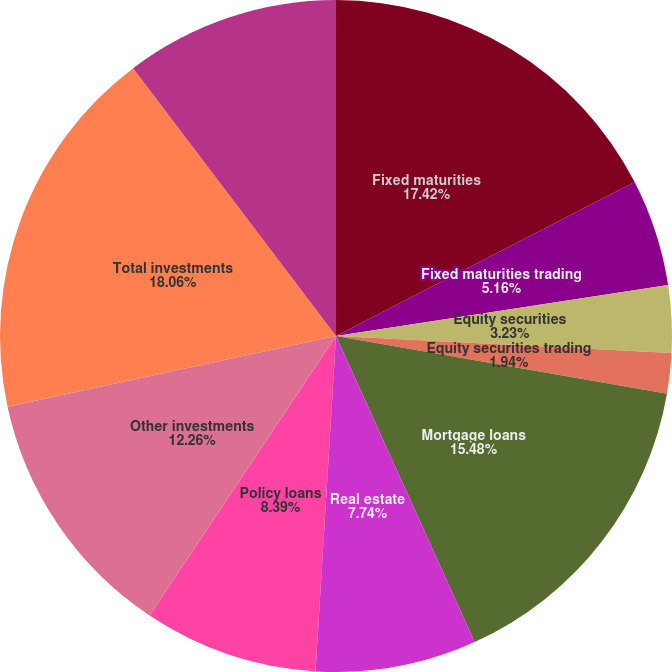Convert chart to OTSL. <chart><loc_0><loc_0><loc_500><loc_500><pie_chart><fcel>Fixed maturities<fcel>Fixed maturities trading<fcel>Equity securities<fcel>Equity securities trading<fcel>Mortgage loans<fcel>Real estate<fcel>Policy loans<fcel>Other investments<fcel>Total investments<fcel>Cash and cash equivalents<nl><fcel>17.42%<fcel>5.16%<fcel>3.23%<fcel>1.94%<fcel>15.48%<fcel>7.74%<fcel>8.39%<fcel>12.26%<fcel>18.06%<fcel>10.32%<nl></chart> 